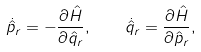Convert formula to latex. <formula><loc_0><loc_0><loc_500><loc_500>\dot { \hat { p } } _ { r } = - \frac { \partial \hat { H } } { \partial \hat { q } _ { r } } , \quad \dot { \hat { q } } _ { r } = \frac { \partial \hat { H } } { \partial \hat { p } _ { r } } ,</formula> 